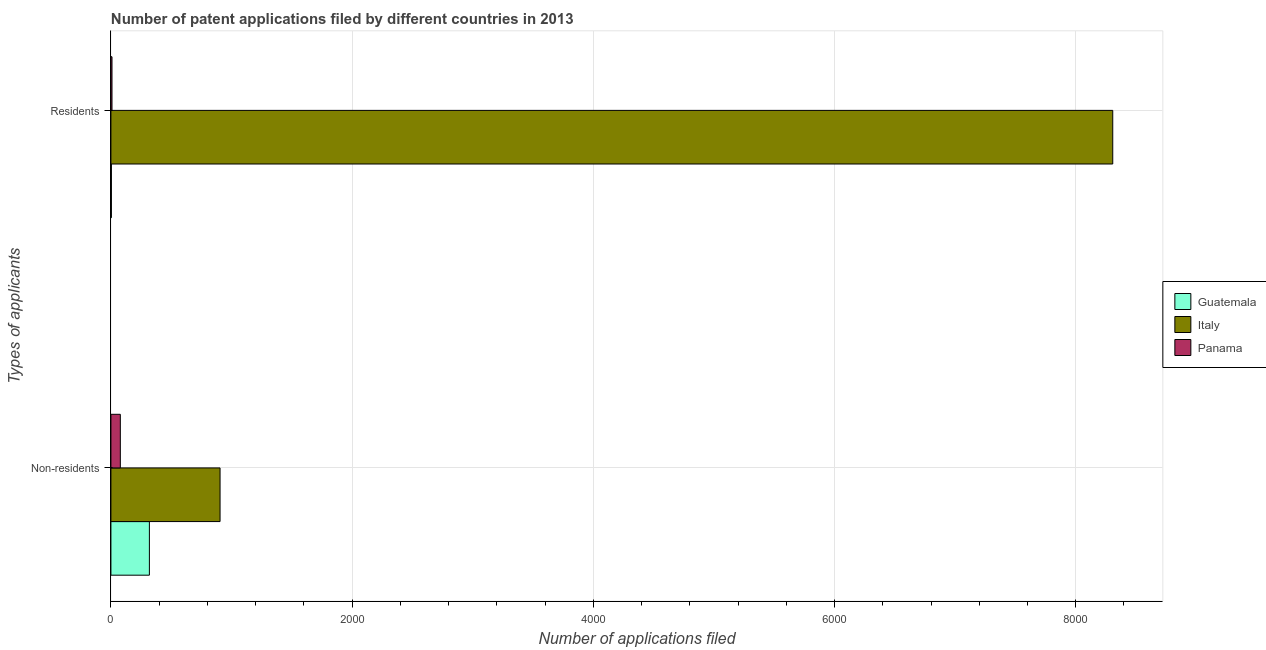Are the number of bars per tick equal to the number of legend labels?
Give a very brief answer. Yes. Are the number of bars on each tick of the Y-axis equal?
Offer a terse response. Yes. How many bars are there on the 2nd tick from the top?
Ensure brevity in your answer.  3. How many bars are there on the 1st tick from the bottom?
Make the answer very short. 3. What is the label of the 1st group of bars from the top?
Your answer should be compact. Residents. What is the number of patent applications by residents in Italy?
Keep it short and to the point. 8307. Across all countries, what is the maximum number of patent applications by non residents?
Keep it short and to the point. 905. Across all countries, what is the minimum number of patent applications by non residents?
Provide a short and direct response. 78. In which country was the number of patent applications by residents minimum?
Provide a succinct answer. Guatemala. What is the total number of patent applications by non residents in the graph?
Keep it short and to the point. 1302. What is the difference between the number of patent applications by non residents in Italy and that in Panama?
Keep it short and to the point. 827. What is the difference between the number of patent applications by non residents in Italy and the number of patent applications by residents in Panama?
Your response must be concise. 896. What is the average number of patent applications by residents per country?
Provide a succinct answer. 2773.33. What is the difference between the number of patent applications by non residents and number of patent applications by residents in Guatemala?
Ensure brevity in your answer.  315. In how many countries, is the number of patent applications by residents greater than 400 ?
Offer a terse response. 1. What is the ratio of the number of patent applications by non residents in Guatemala to that in Panama?
Your answer should be very brief. 4.09. In how many countries, is the number of patent applications by non residents greater than the average number of patent applications by non residents taken over all countries?
Your answer should be compact. 1. What does the 3rd bar from the top in Residents represents?
Make the answer very short. Guatemala. What does the 3rd bar from the bottom in Residents represents?
Offer a terse response. Panama. Are all the bars in the graph horizontal?
Keep it short and to the point. Yes. Are the values on the major ticks of X-axis written in scientific E-notation?
Provide a short and direct response. No. Does the graph contain any zero values?
Provide a succinct answer. No. How many legend labels are there?
Your response must be concise. 3. What is the title of the graph?
Offer a terse response. Number of patent applications filed by different countries in 2013. What is the label or title of the X-axis?
Ensure brevity in your answer.  Number of applications filed. What is the label or title of the Y-axis?
Your answer should be compact. Types of applicants. What is the Number of applications filed in Guatemala in Non-residents?
Give a very brief answer. 319. What is the Number of applications filed in Italy in Non-residents?
Provide a short and direct response. 905. What is the Number of applications filed of Panama in Non-residents?
Offer a very short reply. 78. What is the Number of applications filed in Guatemala in Residents?
Give a very brief answer. 4. What is the Number of applications filed of Italy in Residents?
Give a very brief answer. 8307. Across all Types of applicants, what is the maximum Number of applications filed in Guatemala?
Make the answer very short. 319. Across all Types of applicants, what is the maximum Number of applications filed in Italy?
Offer a very short reply. 8307. Across all Types of applicants, what is the maximum Number of applications filed of Panama?
Your answer should be very brief. 78. Across all Types of applicants, what is the minimum Number of applications filed in Italy?
Provide a short and direct response. 905. Across all Types of applicants, what is the minimum Number of applications filed in Panama?
Make the answer very short. 9. What is the total Number of applications filed in Guatemala in the graph?
Provide a short and direct response. 323. What is the total Number of applications filed in Italy in the graph?
Ensure brevity in your answer.  9212. What is the total Number of applications filed of Panama in the graph?
Your answer should be compact. 87. What is the difference between the Number of applications filed of Guatemala in Non-residents and that in Residents?
Give a very brief answer. 315. What is the difference between the Number of applications filed of Italy in Non-residents and that in Residents?
Provide a succinct answer. -7402. What is the difference between the Number of applications filed of Guatemala in Non-residents and the Number of applications filed of Italy in Residents?
Your answer should be very brief. -7988. What is the difference between the Number of applications filed of Guatemala in Non-residents and the Number of applications filed of Panama in Residents?
Provide a short and direct response. 310. What is the difference between the Number of applications filed of Italy in Non-residents and the Number of applications filed of Panama in Residents?
Make the answer very short. 896. What is the average Number of applications filed in Guatemala per Types of applicants?
Your answer should be very brief. 161.5. What is the average Number of applications filed of Italy per Types of applicants?
Offer a very short reply. 4606. What is the average Number of applications filed of Panama per Types of applicants?
Offer a very short reply. 43.5. What is the difference between the Number of applications filed in Guatemala and Number of applications filed in Italy in Non-residents?
Your response must be concise. -586. What is the difference between the Number of applications filed in Guatemala and Number of applications filed in Panama in Non-residents?
Give a very brief answer. 241. What is the difference between the Number of applications filed of Italy and Number of applications filed of Panama in Non-residents?
Your answer should be compact. 827. What is the difference between the Number of applications filed of Guatemala and Number of applications filed of Italy in Residents?
Make the answer very short. -8303. What is the difference between the Number of applications filed of Italy and Number of applications filed of Panama in Residents?
Your response must be concise. 8298. What is the ratio of the Number of applications filed in Guatemala in Non-residents to that in Residents?
Give a very brief answer. 79.75. What is the ratio of the Number of applications filed of Italy in Non-residents to that in Residents?
Give a very brief answer. 0.11. What is the ratio of the Number of applications filed of Panama in Non-residents to that in Residents?
Provide a short and direct response. 8.67. What is the difference between the highest and the second highest Number of applications filed of Guatemala?
Your answer should be very brief. 315. What is the difference between the highest and the second highest Number of applications filed in Italy?
Offer a very short reply. 7402. What is the difference between the highest and the second highest Number of applications filed of Panama?
Keep it short and to the point. 69. What is the difference between the highest and the lowest Number of applications filed of Guatemala?
Your answer should be compact. 315. What is the difference between the highest and the lowest Number of applications filed of Italy?
Provide a succinct answer. 7402. 